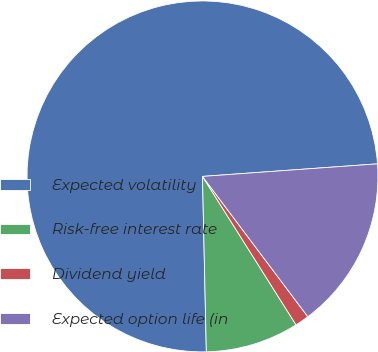Convert chart. <chart><loc_0><loc_0><loc_500><loc_500><pie_chart><fcel>Expected volatility<fcel>Risk-free interest rate<fcel>Dividend yield<fcel>Expected option life (in<nl><fcel>74.21%<fcel>8.6%<fcel>1.3%<fcel>15.89%<nl></chart> 